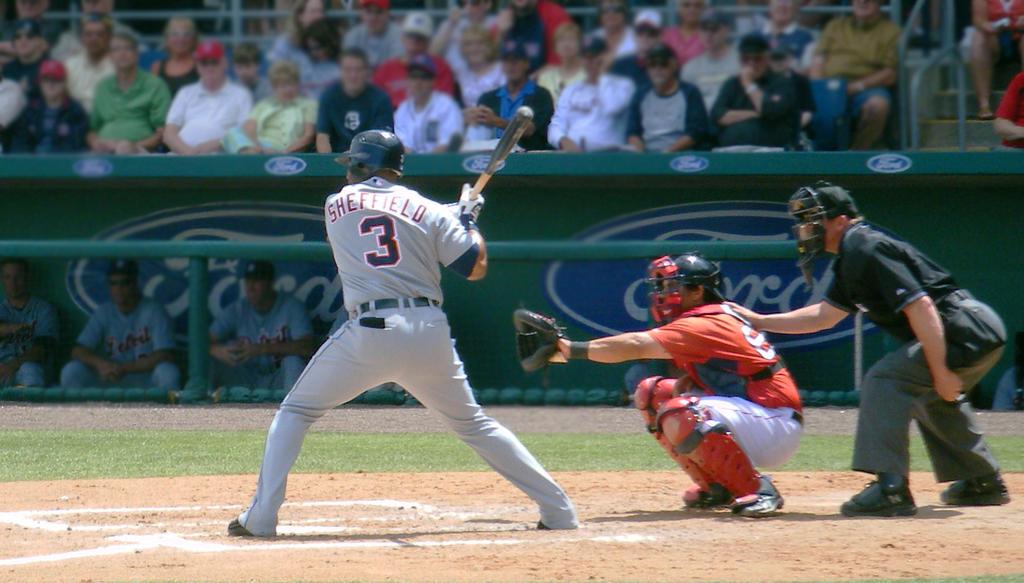What is the number of the player batting?
Ensure brevity in your answer.  3. Which company is the advertiser for the game?
Provide a succinct answer. Ford. 